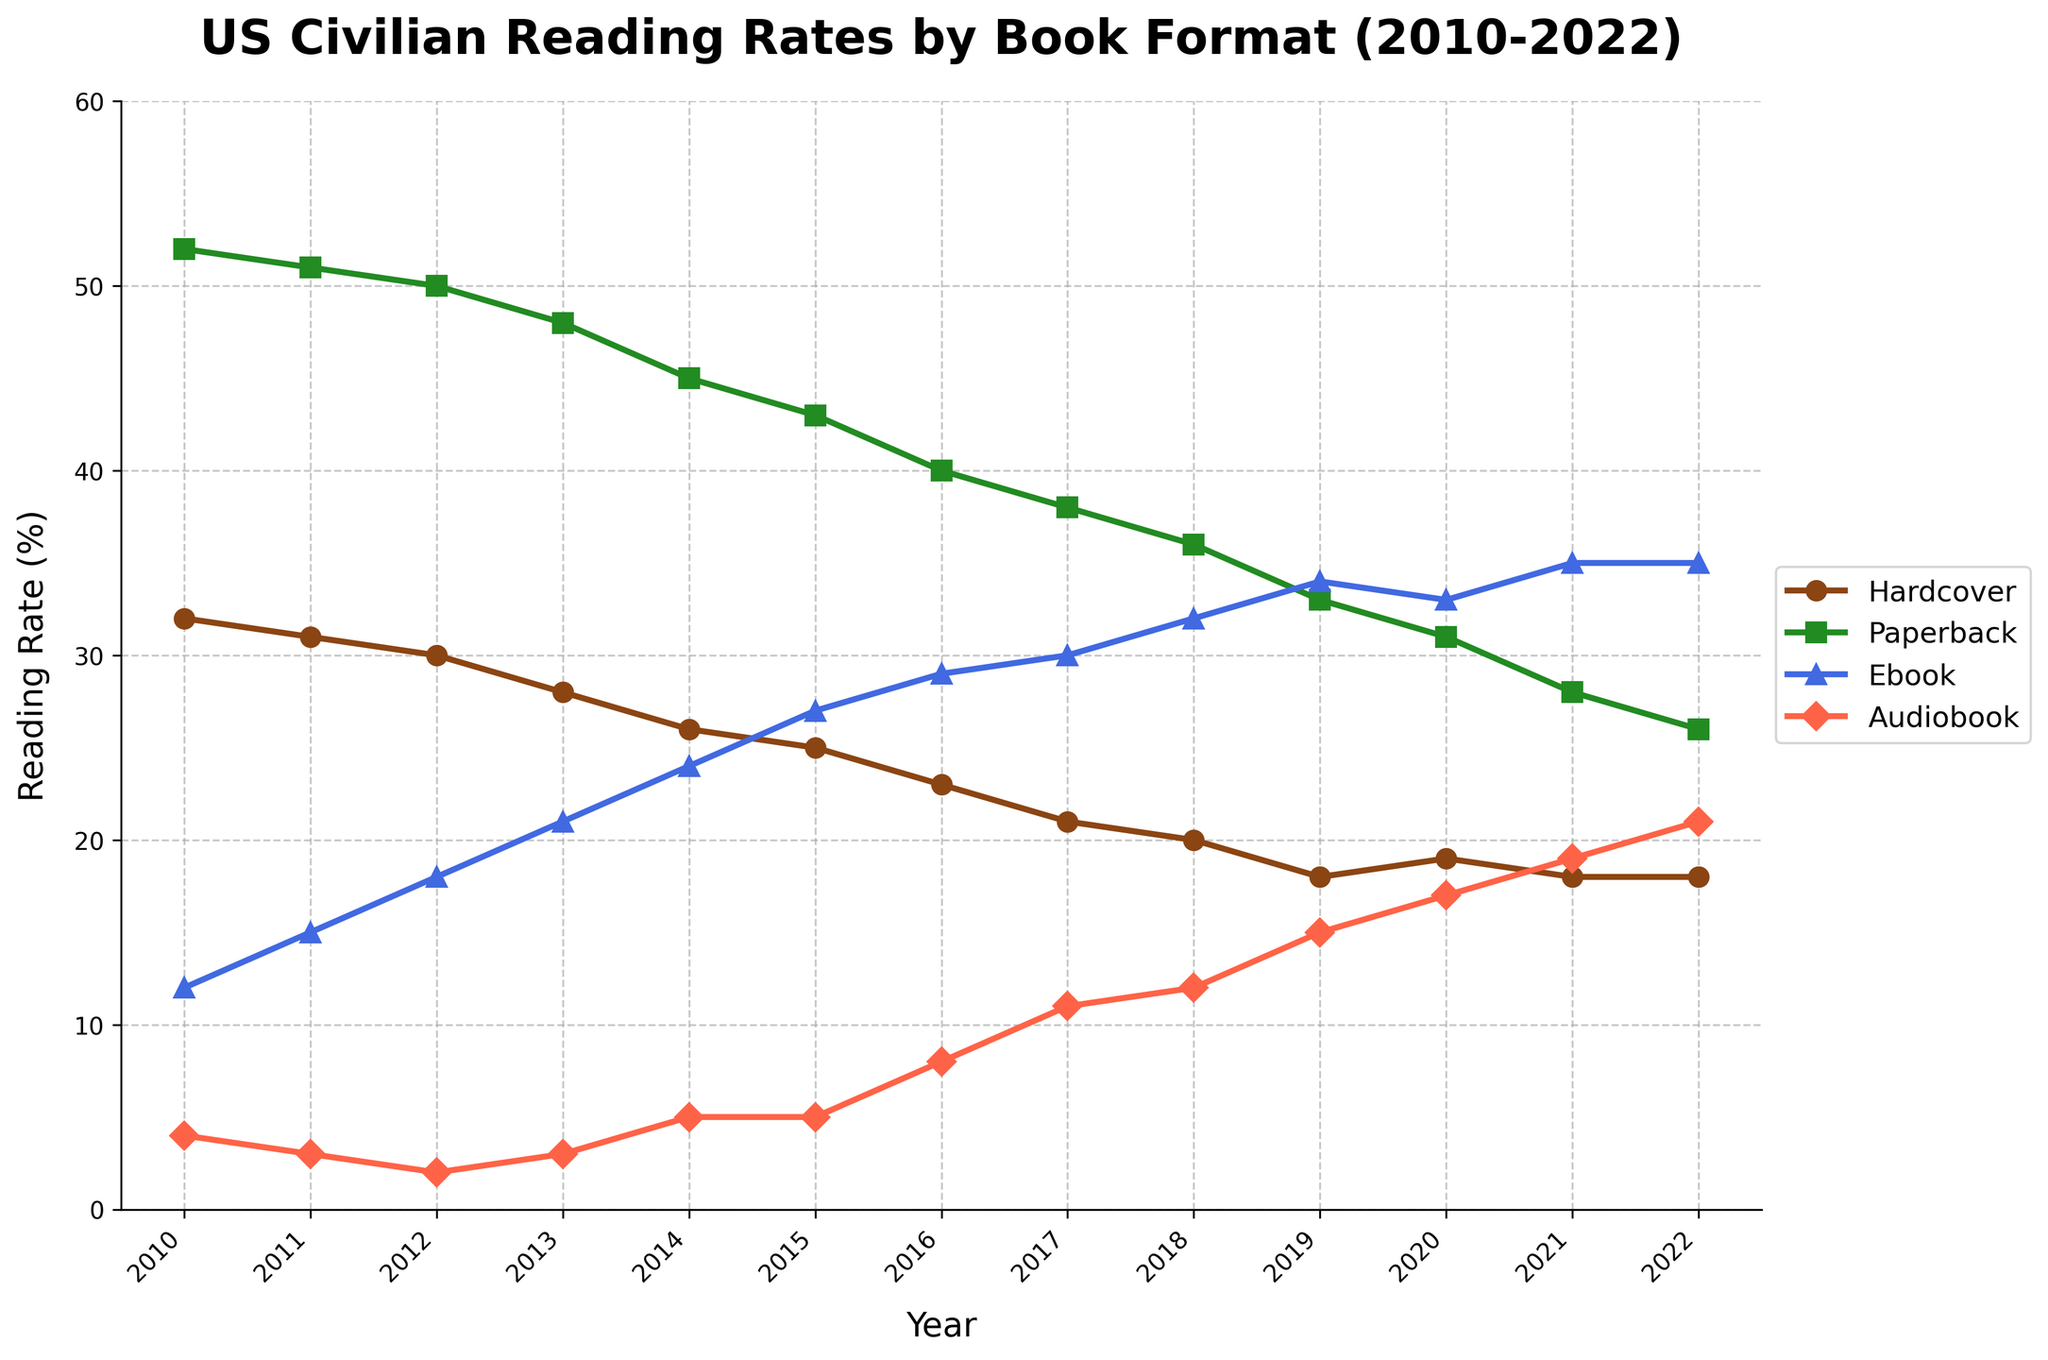What's the title of the figure? The title is displayed at the top of the plot. It provides an overview of what the data represents.
Answer: US Civilian Reading Rates by Book Format (2010-2022) What are the book formats shown in the figure? The book formats can be identified by checking the labels in the legend on the right side of the plot.
Answer: Hardcover, Paperback, Ebook, Audiobook How many years of data are displayed in the figure? The years can be counted from the x-axis, starting from the first year until the last one.
Answer: 13 Which book format had the highest reading rate in 2010? By observing the data points and lines for each book format, check which had the highest value in 2010.
Answer: Paperback What is the trend for Ebook reading rates from 2010 to 2022? To identify the trend, observe the direction of the line for Ebook reading rates over this period.
Answer: Increasing In which year did Audiobook reading rates first exceed Ebook reading rates? Compare the data points over the years to find when the Audiobook reading rate surpassed the Ebook reading rate.
Answer: 2020 What's the difference between the reading rates of Paperback and Ebook in 2015? Look at the values for both formats in 2015 and subtract the Ebook reading rate from the Paperback rate.
Answer: 16% How has the gap between Hardcover and Audiobook reading rates changed from 2010 to 2022? Compare the difference between the reading rates of these two formats in 2010 and 2022 to see if the gap has widened or narrowed.
Answer: Narrowed Which book format showed the most significant increase in reading rate percentage from 2010 to 2022? Calculate the difference for each format between 2010 and 2022 and identify the one with the largest increase.
Answer: Audiobook What conclusion can be drawn about the popularity trends of physical formats versus digital formats over this period? Compare the overall trends of Hardcover and Paperback (physical) with those of Ebook and Audiobook (digital) to draw a conclusion.
Answer: Digital formats increased while physical formats decreased 